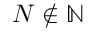Convert formula to latex. <formula><loc_0><loc_0><loc_500><loc_500>N \notin \mathbb { N }</formula> 